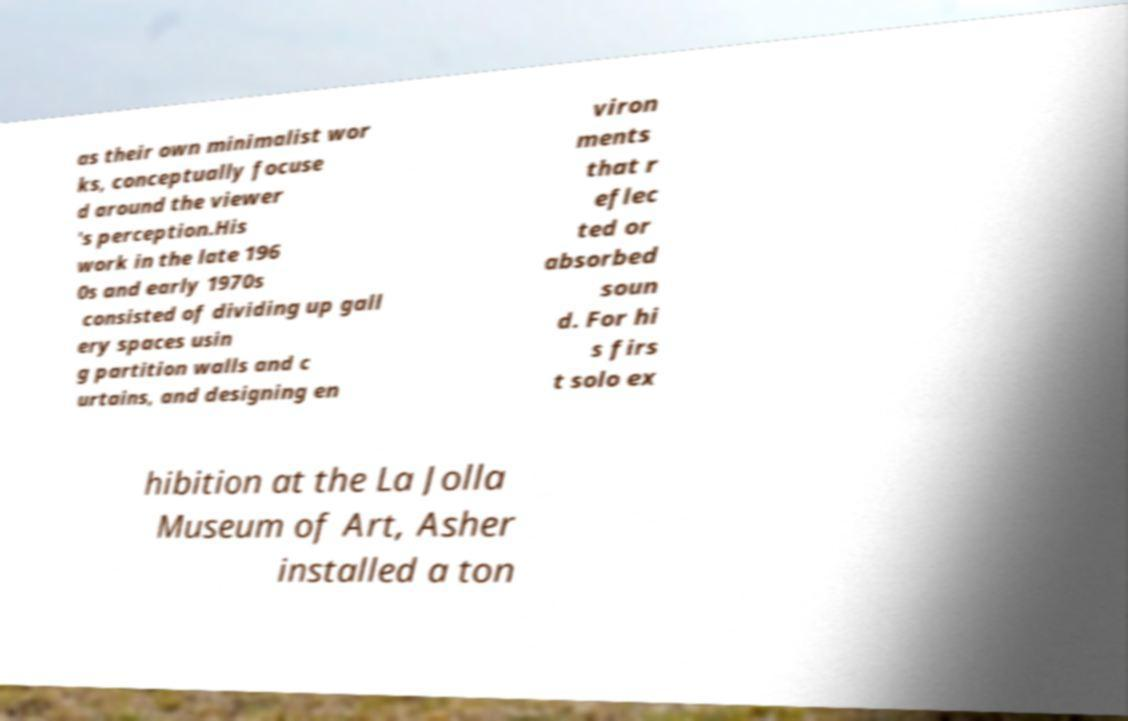Could you assist in decoding the text presented in this image and type it out clearly? as their own minimalist wor ks, conceptually focuse d around the viewer 's perception.His work in the late 196 0s and early 1970s consisted of dividing up gall ery spaces usin g partition walls and c urtains, and designing en viron ments that r eflec ted or absorbed soun d. For hi s firs t solo ex hibition at the La Jolla Museum of Art, Asher installed a ton 